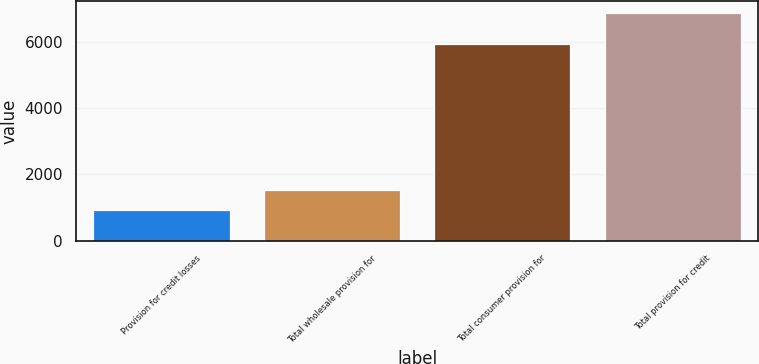Convert chart to OTSL. <chart><loc_0><loc_0><loc_500><loc_500><bar_chart><fcel>Provision for credit losses<fcel>Total wholesale provision for<fcel>Total consumer provision for<fcel>Total provision for credit<nl><fcel>934<fcel>1527<fcel>5930<fcel>6864<nl></chart> 